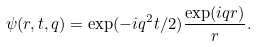Convert formula to latex. <formula><loc_0><loc_0><loc_500><loc_500>\psi ( r , t , q ) = \exp ( - i q ^ { 2 } t / 2 ) \frac { \exp ( i q r ) } { r } .</formula> 